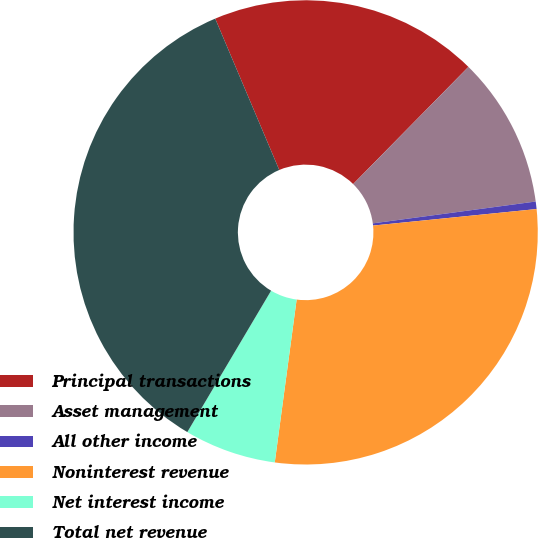<chart> <loc_0><loc_0><loc_500><loc_500><pie_chart><fcel>Principal transactions<fcel>Asset management<fcel>All other income<fcel>Noninterest revenue<fcel>Net interest income<fcel>Total net revenue<nl><fcel>18.74%<fcel>10.51%<fcel>0.52%<fcel>28.73%<fcel>6.39%<fcel>35.12%<nl></chart> 